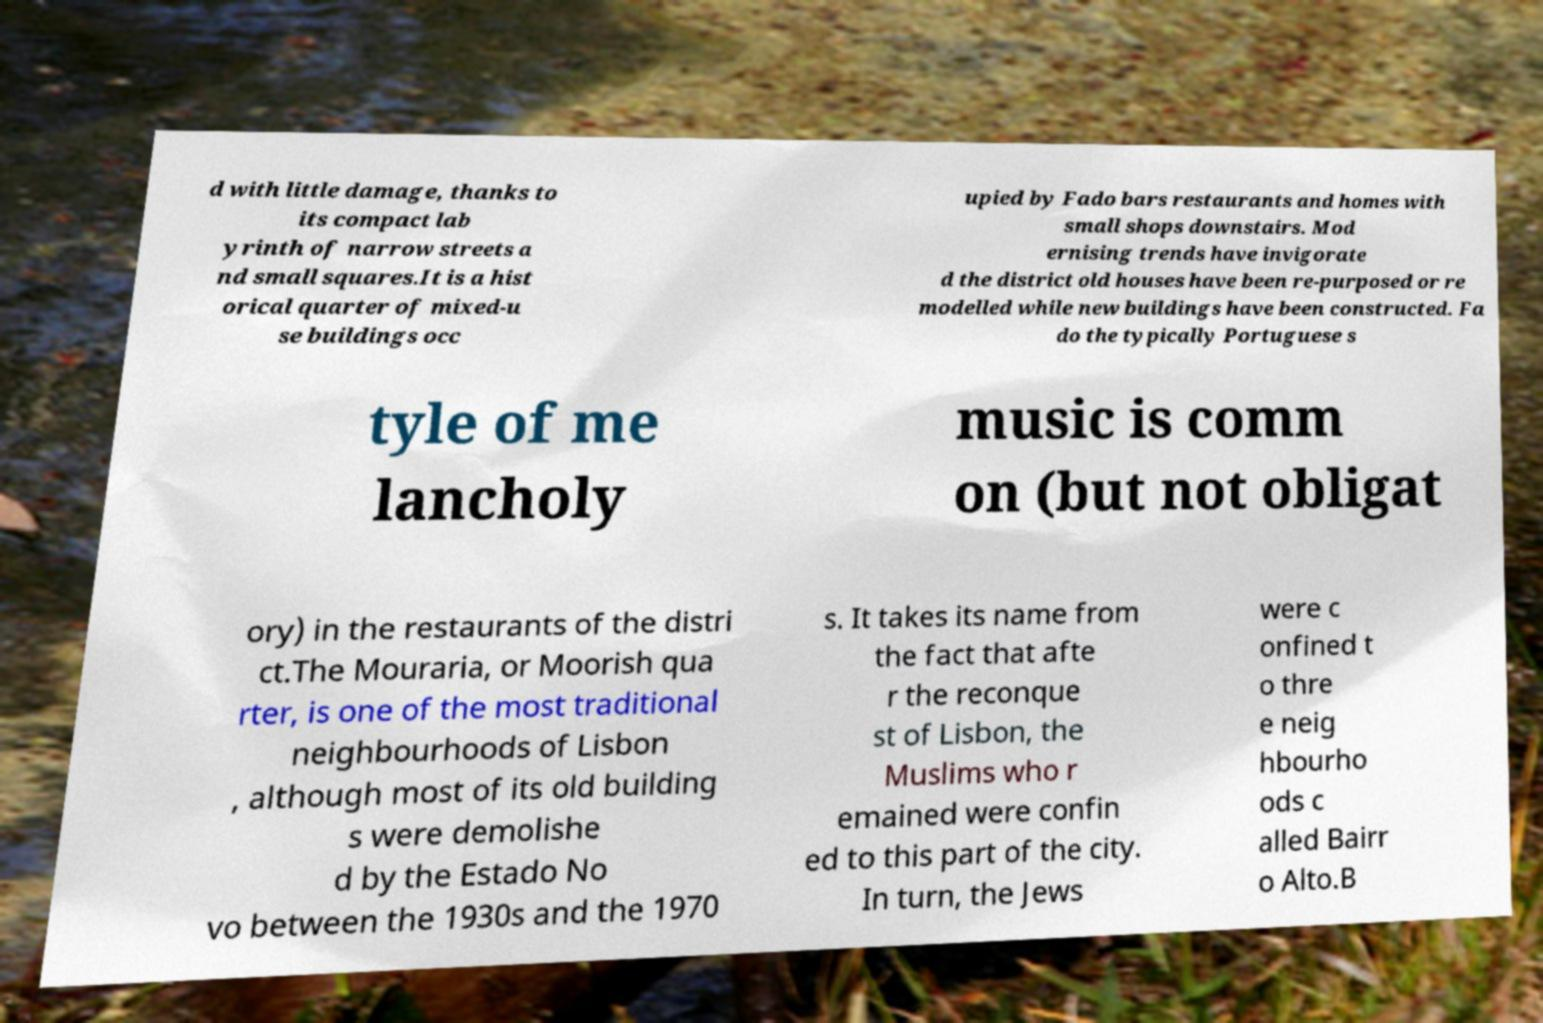Please identify and transcribe the text found in this image. d with little damage, thanks to its compact lab yrinth of narrow streets a nd small squares.It is a hist orical quarter of mixed-u se buildings occ upied by Fado bars restaurants and homes with small shops downstairs. Mod ernising trends have invigorate d the district old houses have been re-purposed or re modelled while new buildings have been constructed. Fa do the typically Portuguese s tyle of me lancholy music is comm on (but not obligat ory) in the restaurants of the distri ct.The Mouraria, or Moorish qua rter, is one of the most traditional neighbourhoods of Lisbon , although most of its old building s were demolishe d by the Estado No vo between the 1930s and the 1970 s. It takes its name from the fact that afte r the reconque st of Lisbon, the Muslims who r emained were confin ed to this part of the city. In turn, the Jews were c onfined t o thre e neig hbourho ods c alled Bairr o Alto.B 